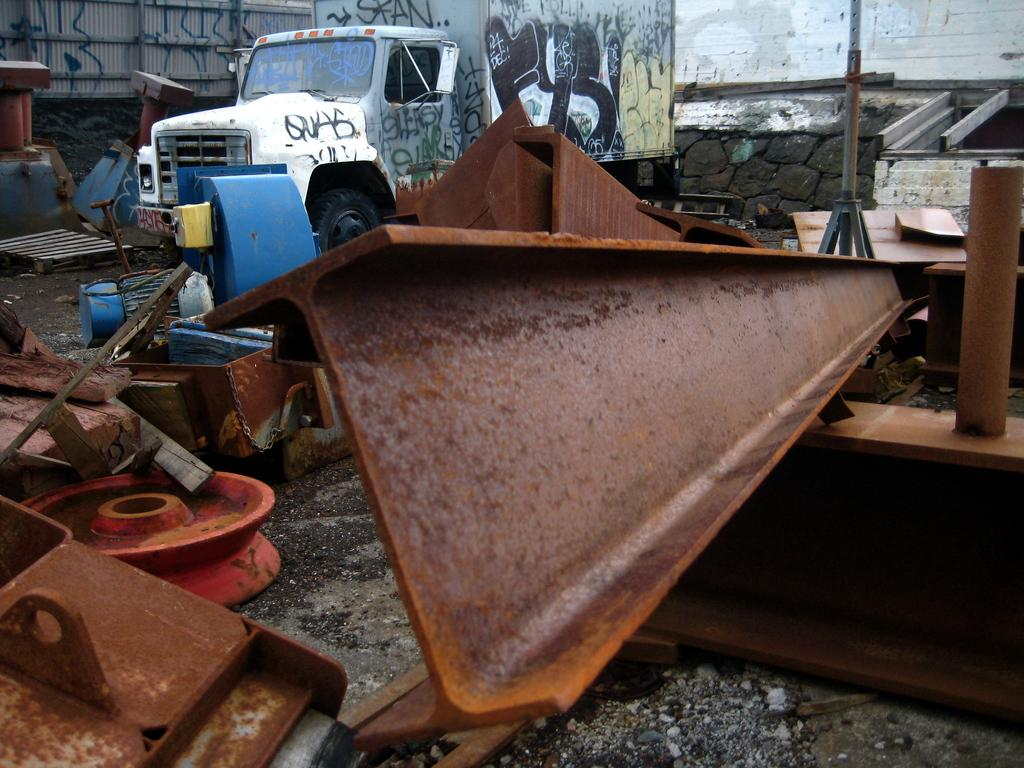What type of objects are present in the image? There are many iron objects in the image. What can be seen in the background of the image? There is a vehicle and a wall in the background of the image. What is special about the vehicle in the image? The vehicle has graffiti on it. What other object can be seen in the image? There is a pole in the image. Can you see a duck swimming in the water in the image? There is no water or duck present in the image. What season is it in the image, considering the presence of summer-related elements? There is no specific season mentioned or depicted in the image, as it only features iron objects, a vehicle, a wall, and a pole. 